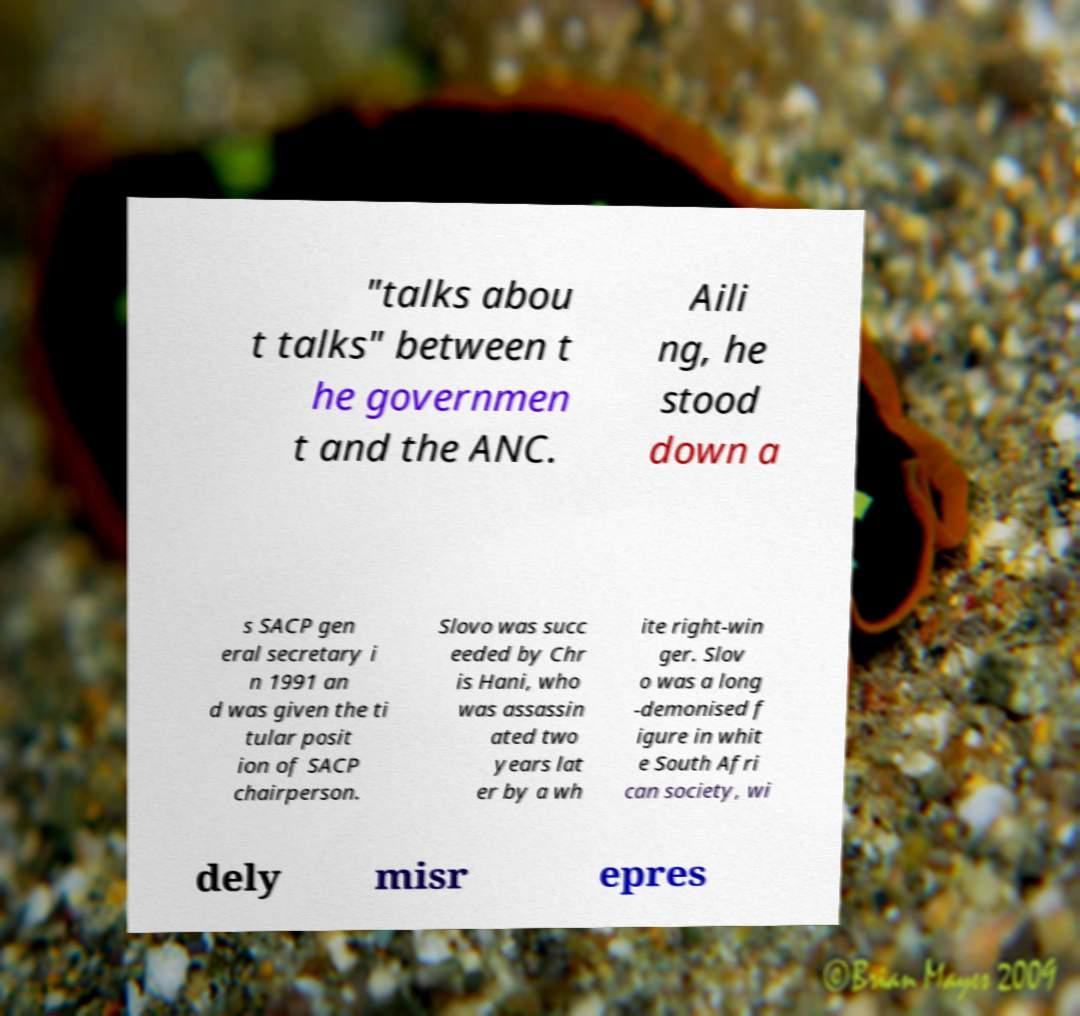What messages or text are displayed in this image? I need them in a readable, typed format. "talks abou t talks" between t he governmen t and the ANC. Aili ng, he stood down a s SACP gen eral secretary i n 1991 an d was given the ti tular posit ion of SACP chairperson. Slovo was succ eeded by Chr is Hani, who was assassin ated two years lat er by a wh ite right-win ger. Slov o was a long -demonised f igure in whit e South Afri can society, wi dely misr epres 